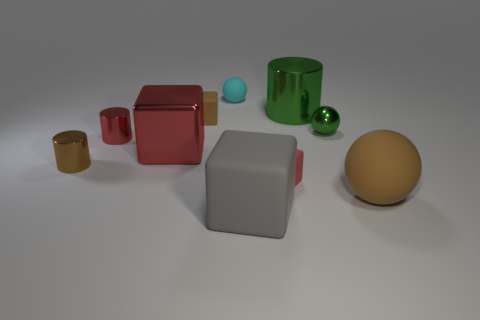Is the number of large green metal cylinders behind the brown cylinder greater than the number of red balls?
Your answer should be compact. Yes. What number of objects are both in front of the small cyan sphere and left of the big brown object?
Offer a very short reply. 8. What is the color of the cylinder to the right of the tiny red metallic object behind the big brown matte thing?
Offer a terse response. Green. What number of matte blocks are the same color as the metallic block?
Your answer should be compact. 1. Is the color of the big shiny cylinder the same as the small shiny thing that is right of the metallic block?
Provide a succinct answer. Yes. Is the number of tiny shiny cylinders less than the number of cyan things?
Ensure brevity in your answer.  No. Is the number of big objects that are to the right of the small red rubber cube greater than the number of cyan balls that are right of the large green metal thing?
Give a very brief answer. Yes. Is the small cyan sphere made of the same material as the green cylinder?
Make the answer very short. No. What number of big green shiny things are behind the large metallic object that is to the left of the green shiny cylinder?
Ensure brevity in your answer.  1. There is a small cube in front of the brown cylinder; is its color the same as the big metal cube?
Your answer should be very brief. Yes. 